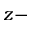<formula> <loc_0><loc_0><loc_500><loc_500>z -</formula> 